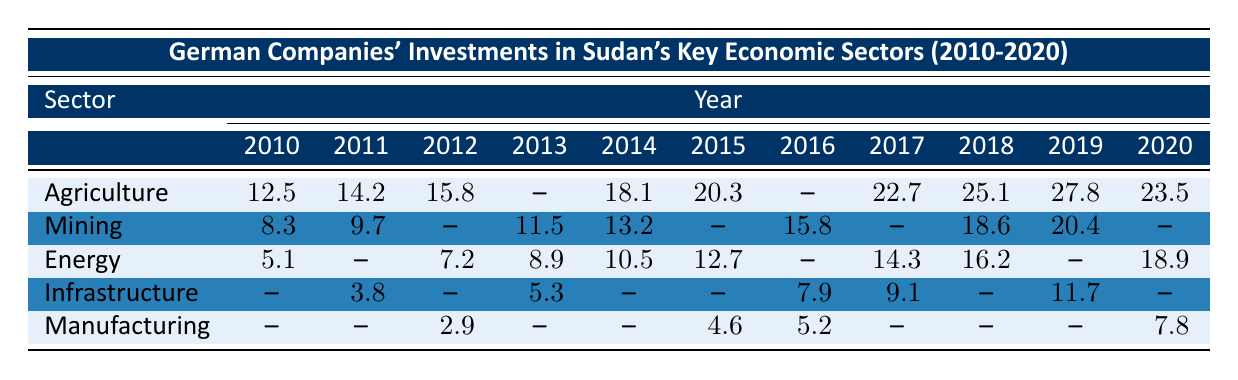What was the total investment in Agriculture from 2010 to 2020? The investments in Agriculture for the years 2010 to 2020 are 12.5, 14.2, 15.8, 18.1, 20.3, 22.7, 25.1, 27.8, and 23.5. Summing these values gives 12.5 + 14.2 + 15.8 + 18.1 + 20.3 + 22.7 + 25.1 + 27.8 + 23.5 =  179.0
Answer: 179.0 What was the highest investment in Mining, and in which year did it occur? The investments in Mining are 8.3, 9.7, 11.5, 13.2, 15.8, 18.6, and 20.4. The highest value is 20.4 in the year 2019.
Answer: 20.4, 2019 What was the total investment in Energy in 2015 and 2016? The investments in Energy for 2015 and 2016 are 12.7 and 0 (no investment in 2016 represented by --). Summing these values gives 12.7 + 0 = 12.7.
Answer: 12.7 In which year did Manufacturing have the lowest investment, and what was that amount? The investments in Manufacturing are 2.9, 0 (no investment in 2011), 4.6, 5.2, 0 (no investment in 2018), and 7.8. The lowest investment occurred in 2012 with 2.9.
Answer: 2012, 2.9 What is the average investment in Infrastructure over the years it was recorded? The recorded investments in Infrastructure are 3.8, 5.3, 7.9, 9.1, and 11.7. There are 5 data points with a total investment of 3.8 + 5.3 + 7.9 + 9.1 + 11.7 = 37.8. The average is 37.8 / 5 = 7.56.
Answer: 7.56 Was there any investment in Infrastructure in 2010? There is no recorded investment in Infrastructure for 2010, represented by -- in the table.
Answer: No What sector received the highest total investment from 2010 to 2020? The total investment from 2010 to 2020 for each sector needs to be calculated: Agriculture = 179.0, Mining = 107.7 (8.3 + 9.7 + 11.5 + 13.2 + 15.8 + 18.6 + 20.4 = 107.7), Energy = 78.0, Infrastructure = 38.8, Manufacturing = 20.5. The highest total investment is for Agriculture at 179.0.
Answer: Agriculture What was the increase in investment in Agriculture from 2010 to 2018? The investment in Agriculture in 2010 was 12.5, and in 2018 it was 25.1. The increase is 25.1 - 12.5 = 12.6.
Answer: 12.6 True or False: The total investment in Energy in 2020 was higher than in 2018. The investment in Energy in 2020 was 18.9, and in 2018 it was 16.2. Thus, 18.9 is higher than 16.2.
Answer: True What year had no recorded investment in Manufacturing? The years without recorded investment in Manufacturing are 2010 and 2011, represented by --.
Answer: 2010, 2011 